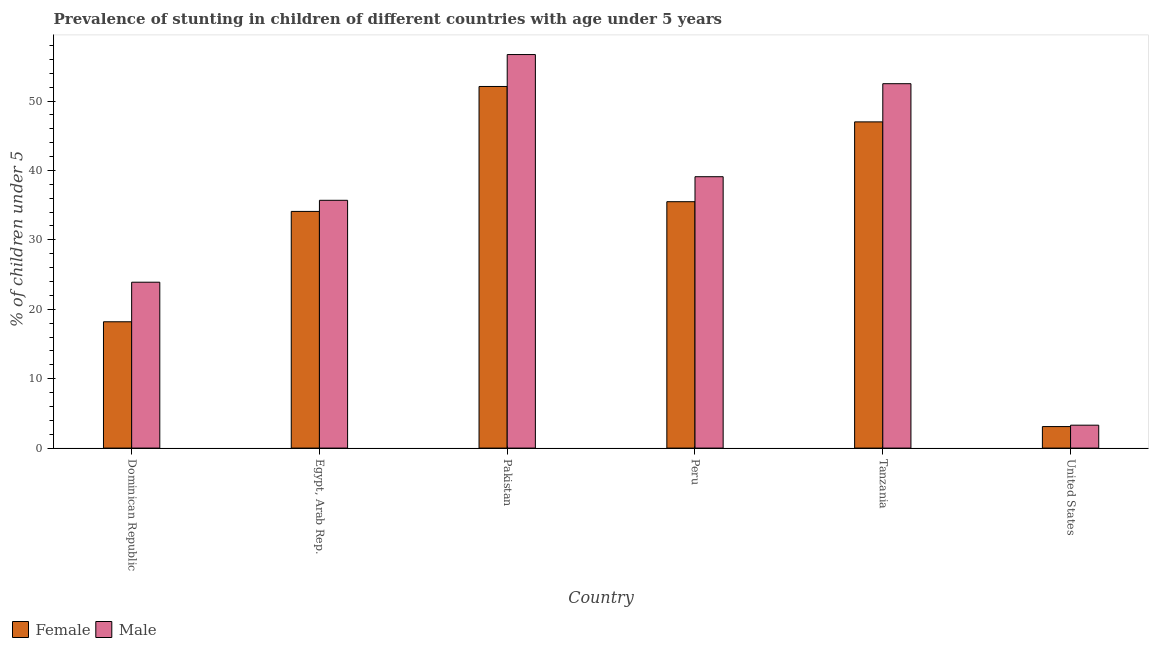How many different coloured bars are there?
Your answer should be very brief. 2. Are the number of bars on each tick of the X-axis equal?
Your answer should be very brief. Yes. How many bars are there on the 5th tick from the right?
Give a very brief answer. 2. In how many cases, is the number of bars for a given country not equal to the number of legend labels?
Offer a very short reply. 0. What is the percentage of stunted female children in United States?
Offer a terse response. 3.1. Across all countries, what is the maximum percentage of stunted female children?
Your answer should be compact. 52.1. Across all countries, what is the minimum percentage of stunted male children?
Your answer should be compact. 3.3. In which country was the percentage of stunted male children maximum?
Offer a very short reply. Pakistan. What is the total percentage of stunted male children in the graph?
Provide a succinct answer. 211.2. What is the difference between the percentage of stunted female children in Tanzania and that in United States?
Your response must be concise. 43.9. What is the difference between the percentage of stunted male children in United States and the percentage of stunted female children in Dominican Republic?
Provide a succinct answer. -14.9. What is the average percentage of stunted female children per country?
Your response must be concise. 31.67. What is the difference between the percentage of stunted male children and percentage of stunted female children in Tanzania?
Offer a very short reply. 5.5. What is the ratio of the percentage of stunted female children in Dominican Republic to that in United States?
Provide a succinct answer. 5.87. Is the percentage of stunted female children in Egypt, Arab Rep. less than that in Pakistan?
Your answer should be very brief. Yes. Is the difference between the percentage of stunted male children in Dominican Republic and Pakistan greater than the difference between the percentage of stunted female children in Dominican Republic and Pakistan?
Offer a terse response. Yes. What is the difference between the highest and the second highest percentage of stunted male children?
Your answer should be compact. 4.2. What is the difference between the highest and the lowest percentage of stunted male children?
Offer a terse response. 53.4. Is the sum of the percentage of stunted female children in Egypt, Arab Rep. and Peru greater than the maximum percentage of stunted male children across all countries?
Give a very brief answer. Yes. What does the 2nd bar from the left in Tanzania represents?
Offer a terse response. Male. What does the 1st bar from the right in Pakistan represents?
Make the answer very short. Male. What is the difference between two consecutive major ticks on the Y-axis?
Keep it short and to the point. 10. Are the values on the major ticks of Y-axis written in scientific E-notation?
Your answer should be very brief. No. Does the graph contain any zero values?
Your answer should be very brief. No. Does the graph contain grids?
Make the answer very short. No. Where does the legend appear in the graph?
Your response must be concise. Bottom left. How many legend labels are there?
Provide a succinct answer. 2. What is the title of the graph?
Make the answer very short. Prevalence of stunting in children of different countries with age under 5 years. What is the label or title of the X-axis?
Ensure brevity in your answer.  Country. What is the label or title of the Y-axis?
Your response must be concise.  % of children under 5. What is the  % of children under 5 in Female in Dominican Republic?
Your answer should be very brief. 18.2. What is the  % of children under 5 in Male in Dominican Republic?
Your answer should be very brief. 23.9. What is the  % of children under 5 in Female in Egypt, Arab Rep.?
Ensure brevity in your answer.  34.1. What is the  % of children under 5 in Male in Egypt, Arab Rep.?
Your answer should be compact. 35.7. What is the  % of children under 5 of Female in Pakistan?
Provide a succinct answer. 52.1. What is the  % of children under 5 of Male in Pakistan?
Your answer should be very brief. 56.7. What is the  % of children under 5 of Female in Peru?
Your response must be concise. 35.5. What is the  % of children under 5 of Male in Peru?
Make the answer very short. 39.1. What is the  % of children under 5 of Female in Tanzania?
Make the answer very short. 47. What is the  % of children under 5 in Male in Tanzania?
Offer a terse response. 52.5. What is the  % of children under 5 in Female in United States?
Provide a short and direct response. 3.1. What is the  % of children under 5 in Male in United States?
Keep it short and to the point. 3.3. Across all countries, what is the maximum  % of children under 5 in Female?
Provide a short and direct response. 52.1. Across all countries, what is the maximum  % of children under 5 in Male?
Provide a succinct answer. 56.7. Across all countries, what is the minimum  % of children under 5 in Female?
Your answer should be compact. 3.1. Across all countries, what is the minimum  % of children under 5 of Male?
Your answer should be very brief. 3.3. What is the total  % of children under 5 of Female in the graph?
Make the answer very short. 190. What is the total  % of children under 5 of Male in the graph?
Your answer should be compact. 211.2. What is the difference between the  % of children under 5 of Female in Dominican Republic and that in Egypt, Arab Rep.?
Provide a short and direct response. -15.9. What is the difference between the  % of children under 5 of Female in Dominican Republic and that in Pakistan?
Ensure brevity in your answer.  -33.9. What is the difference between the  % of children under 5 of Male in Dominican Republic and that in Pakistan?
Your response must be concise. -32.8. What is the difference between the  % of children under 5 of Female in Dominican Republic and that in Peru?
Your answer should be compact. -17.3. What is the difference between the  % of children under 5 in Male in Dominican Republic and that in Peru?
Keep it short and to the point. -15.2. What is the difference between the  % of children under 5 of Female in Dominican Republic and that in Tanzania?
Your response must be concise. -28.8. What is the difference between the  % of children under 5 in Male in Dominican Republic and that in Tanzania?
Your answer should be compact. -28.6. What is the difference between the  % of children under 5 in Male in Dominican Republic and that in United States?
Make the answer very short. 20.6. What is the difference between the  % of children under 5 in Female in Egypt, Arab Rep. and that in Pakistan?
Provide a short and direct response. -18. What is the difference between the  % of children under 5 of Male in Egypt, Arab Rep. and that in Peru?
Make the answer very short. -3.4. What is the difference between the  % of children under 5 of Female in Egypt, Arab Rep. and that in Tanzania?
Keep it short and to the point. -12.9. What is the difference between the  % of children under 5 of Male in Egypt, Arab Rep. and that in Tanzania?
Your answer should be very brief. -16.8. What is the difference between the  % of children under 5 in Female in Egypt, Arab Rep. and that in United States?
Make the answer very short. 31. What is the difference between the  % of children under 5 in Male in Egypt, Arab Rep. and that in United States?
Your answer should be compact. 32.4. What is the difference between the  % of children under 5 in Female in Pakistan and that in Peru?
Offer a terse response. 16.6. What is the difference between the  % of children under 5 of Male in Pakistan and that in Tanzania?
Ensure brevity in your answer.  4.2. What is the difference between the  % of children under 5 in Female in Pakistan and that in United States?
Provide a succinct answer. 49. What is the difference between the  % of children under 5 of Male in Pakistan and that in United States?
Your answer should be very brief. 53.4. What is the difference between the  % of children under 5 of Female in Peru and that in Tanzania?
Offer a very short reply. -11.5. What is the difference between the  % of children under 5 of Male in Peru and that in Tanzania?
Your answer should be very brief. -13.4. What is the difference between the  % of children under 5 of Female in Peru and that in United States?
Ensure brevity in your answer.  32.4. What is the difference between the  % of children under 5 in Male in Peru and that in United States?
Give a very brief answer. 35.8. What is the difference between the  % of children under 5 in Female in Tanzania and that in United States?
Offer a very short reply. 43.9. What is the difference between the  % of children under 5 of Male in Tanzania and that in United States?
Keep it short and to the point. 49.2. What is the difference between the  % of children under 5 in Female in Dominican Republic and the  % of children under 5 in Male in Egypt, Arab Rep.?
Your answer should be very brief. -17.5. What is the difference between the  % of children under 5 in Female in Dominican Republic and the  % of children under 5 in Male in Pakistan?
Ensure brevity in your answer.  -38.5. What is the difference between the  % of children under 5 in Female in Dominican Republic and the  % of children under 5 in Male in Peru?
Make the answer very short. -20.9. What is the difference between the  % of children under 5 of Female in Dominican Republic and the  % of children under 5 of Male in Tanzania?
Your answer should be very brief. -34.3. What is the difference between the  % of children under 5 of Female in Egypt, Arab Rep. and the  % of children under 5 of Male in Pakistan?
Offer a very short reply. -22.6. What is the difference between the  % of children under 5 of Female in Egypt, Arab Rep. and the  % of children under 5 of Male in Peru?
Your answer should be very brief. -5. What is the difference between the  % of children under 5 of Female in Egypt, Arab Rep. and the  % of children under 5 of Male in Tanzania?
Ensure brevity in your answer.  -18.4. What is the difference between the  % of children under 5 in Female in Egypt, Arab Rep. and the  % of children under 5 in Male in United States?
Offer a very short reply. 30.8. What is the difference between the  % of children under 5 in Female in Pakistan and the  % of children under 5 in Male in Peru?
Offer a very short reply. 13. What is the difference between the  % of children under 5 in Female in Pakistan and the  % of children under 5 in Male in Tanzania?
Your response must be concise. -0.4. What is the difference between the  % of children under 5 of Female in Pakistan and the  % of children under 5 of Male in United States?
Offer a very short reply. 48.8. What is the difference between the  % of children under 5 of Female in Peru and the  % of children under 5 of Male in United States?
Your response must be concise. 32.2. What is the difference between the  % of children under 5 of Female in Tanzania and the  % of children under 5 of Male in United States?
Give a very brief answer. 43.7. What is the average  % of children under 5 of Female per country?
Offer a terse response. 31.67. What is the average  % of children under 5 of Male per country?
Offer a very short reply. 35.2. What is the difference between the  % of children under 5 of Female and  % of children under 5 of Male in Dominican Republic?
Your response must be concise. -5.7. What is the ratio of the  % of children under 5 of Female in Dominican Republic to that in Egypt, Arab Rep.?
Offer a terse response. 0.53. What is the ratio of the  % of children under 5 of Male in Dominican Republic to that in Egypt, Arab Rep.?
Make the answer very short. 0.67. What is the ratio of the  % of children under 5 of Female in Dominican Republic to that in Pakistan?
Provide a succinct answer. 0.35. What is the ratio of the  % of children under 5 in Male in Dominican Republic to that in Pakistan?
Keep it short and to the point. 0.42. What is the ratio of the  % of children under 5 in Female in Dominican Republic to that in Peru?
Make the answer very short. 0.51. What is the ratio of the  % of children under 5 in Male in Dominican Republic to that in Peru?
Give a very brief answer. 0.61. What is the ratio of the  % of children under 5 in Female in Dominican Republic to that in Tanzania?
Keep it short and to the point. 0.39. What is the ratio of the  % of children under 5 of Male in Dominican Republic to that in Tanzania?
Ensure brevity in your answer.  0.46. What is the ratio of the  % of children under 5 of Female in Dominican Republic to that in United States?
Offer a terse response. 5.87. What is the ratio of the  % of children under 5 in Male in Dominican Republic to that in United States?
Your answer should be compact. 7.24. What is the ratio of the  % of children under 5 in Female in Egypt, Arab Rep. to that in Pakistan?
Provide a short and direct response. 0.65. What is the ratio of the  % of children under 5 in Male in Egypt, Arab Rep. to that in Pakistan?
Your answer should be very brief. 0.63. What is the ratio of the  % of children under 5 of Female in Egypt, Arab Rep. to that in Peru?
Offer a very short reply. 0.96. What is the ratio of the  % of children under 5 in Male in Egypt, Arab Rep. to that in Peru?
Your response must be concise. 0.91. What is the ratio of the  % of children under 5 of Female in Egypt, Arab Rep. to that in Tanzania?
Make the answer very short. 0.73. What is the ratio of the  % of children under 5 of Male in Egypt, Arab Rep. to that in Tanzania?
Your answer should be compact. 0.68. What is the ratio of the  % of children under 5 in Male in Egypt, Arab Rep. to that in United States?
Ensure brevity in your answer.  10.82. What is the ratio of the  % of children under 5 of Female in Pakistan to that in Peru?
Your answer should be very brief. 1.47. What is the ratio of the  % of children under 5 in Male in Pakistan to that in Peru?
Offer a terse response. 1.45. What is the ratio of the  % of children under 5 of Female in Pakistan to that in Tanzania?
Keep it short and to the point. 1.11. What is the ratio of the  % of children under 5 in Male in Pakistan to that in Tanzania?
Your answer should be very brief. 1.08. What is the ratio of the  % of children under 5 of Female in Pakistan to that in United States?
Your response must be concise. 16.81. What is the ratio of the  % of children under 5 in Male in Pakistan to that in United States?
Offer a terse response. 17.18. What is the ratio of the  % of children under 5 in Female in Peru to that in Tanzania?
Make the answer very short. 0.76. What is the ratio of the  % of children under 5 in Male in Peru to that in Tanzania?
Ensure brevity in your answer.  0.74. What is the ratio of the  % of children under 5 in Female in Peru to that in United States?
Offer a terse response. 11.45. What is the ratio of the  % of children under 5 in Male in Peru to that in United States?
Offer a very short reply. 11.85. What is the ratio of the  % of children under 5 in Female in Tanzania to that in United States?
Offer a very short reply. 15.16. What is the ratio of the  % of children under 5 in Male in Tanzania to that in United States?
Make the answer very short. 15.91. What is the difference between the highest and the second highest  % of children under 5 in Female?
Your answer should be compact. 5.1. What is the difference between the highest and the second highest  % of children under 5 in Male?
Ensure brevity in your answer.  4.2. What is the difference between the highest and the lowest  % of children under 5 of Male?
Provide a succinct answer. 53.4. 